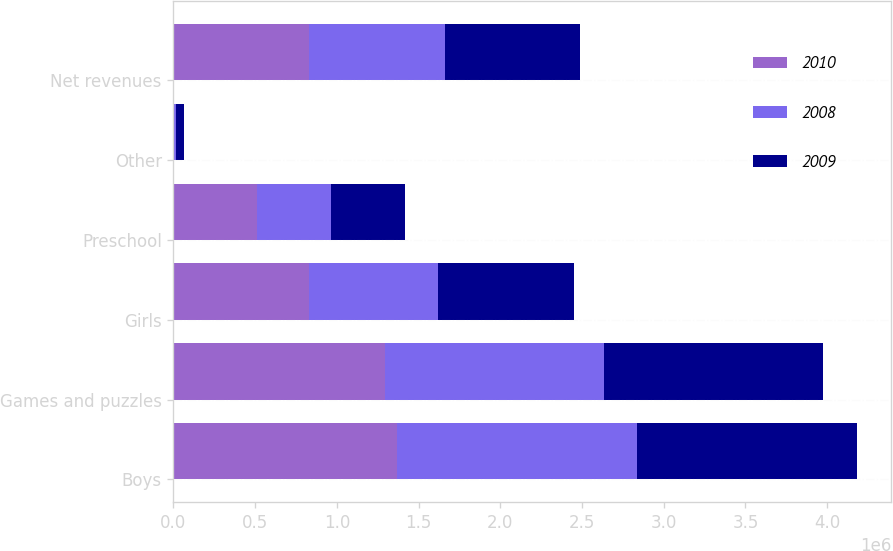Convert chart to OTSL. <chart><loc_0><loc_0><loc_500><loc_500><stacked_bar_chart><ecel><fcel>Boys<fcel>Games and puzzles<fcel>Girls<fcel>Preschool<fcel>Other<fcel>Net revenues<nl><fcel>2010<fcel>1.36781e+06<fcel>1.29377e+06<fcel>830383<fcel>509570<fcel>624<fcel>829785<nl><fcel>2008<fcel>1.47098e+06<fcel>1.34089e+06<fcel>790817<fcel>451401<fcel>13868<fcel>829785<nl><fcel>2009<fcel>1.34467e+06<fcel>1.33991e+06<fcel>829785<fcel>456791<fcel>50363<fcel>829785<nl></chart> 